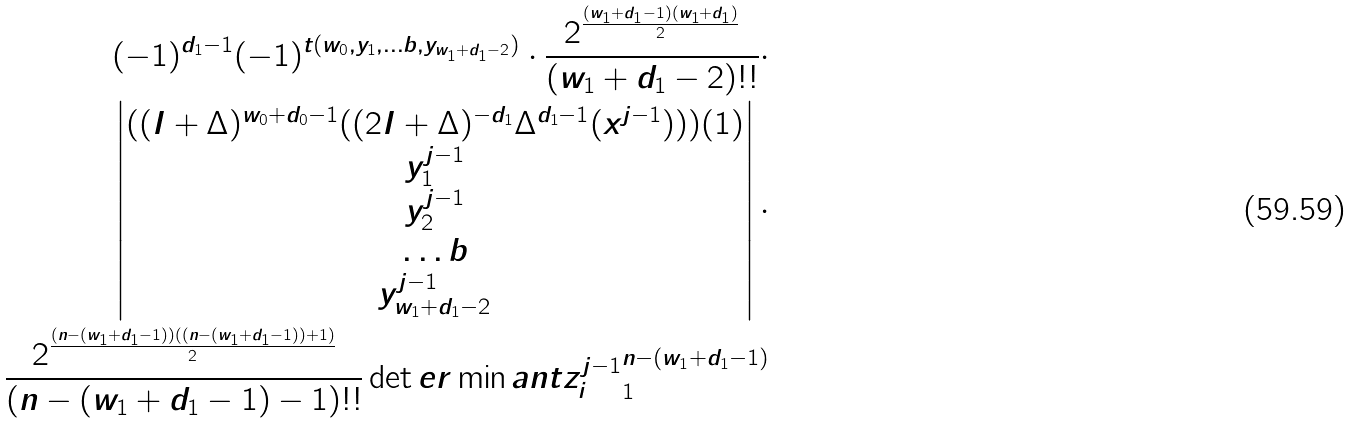Convert formula to latex. <formula><loc_0><loc_0><loc_500><loc_500>( - 1 ) ^ { d _ { 1 } - 1 } ( - 1 ) ^ { t ( w _ { 0 } , y _ { 1 } , \dots b , y _ { w _ { 1 } + d _ { 1 } - 2 } ) } \cdot \frac { 2 ^ { \frac { ( w _ { 1 } + d _ { 1 } - 1 ) ( w _ { 1 } + d _ { 1 } ) } { 2 } } } { ( w _ { 1 } + d _ { 1 } - 2 ) ! ! } \cdot \\ \begin{vmatrix} ( ( I + \Delta ) ^ { w _ { 0 } + d _ { 0 } - 1 } ( ( 2 I + \Delta ) ^ { - d _ { 1 } } \Delta ^ { d _ { 1 } - 1 } ( x ^ { j - 1 } ) ) ) ( 1 ) \\ y _ { 1 } ^ { j - 1 } \\ y _ { 2 } ^ { j - 1 } \\ \dots b \\ y _ { w _ { 1 } + d _ { 1 } - 2 } ^ { j - 1 } \end{vmatrix} \cdot \\ \frac { 2 ^ { \frac { ( n - ( w _ { 1 } + d _ { 1 } - 1 ) ) ( ( n - ( w _ { 1 } + d _ { 1 } - 1 ) ) + 1 ) } { 2 } } } { ( n - ( w _ { 1 } + d _ { 1 } - 1 ) - 1 ) ! ! } \det e r \min a n t { z _ { i } ^ { j - 1 } } _ { 1 } ^ { n - ( w _ { 1 } + d _ { 1 } - 1 ) }</formula> 